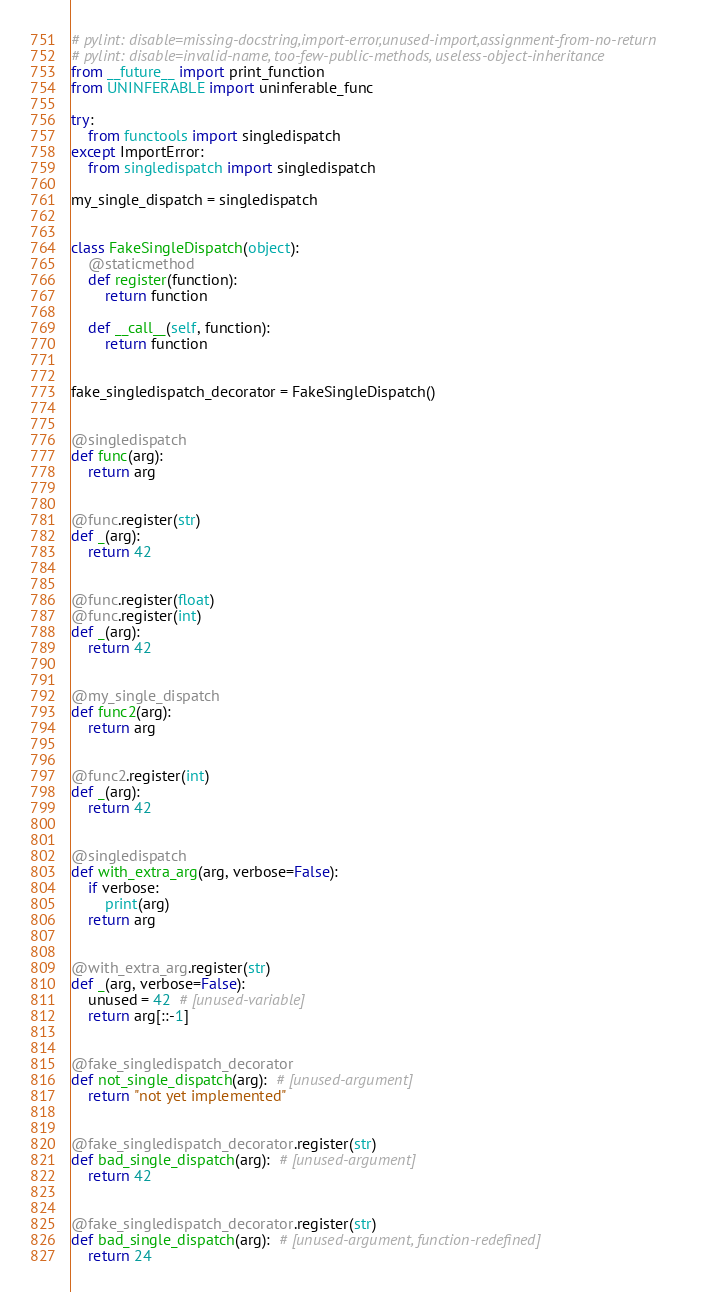<code> <loc_0><loc_0><loc_500><loc_500><_Python_># pylint: disable=missing-docstring,import-error,unused-import,assignment-from-no-return
# pylint: disable=invalid-name, too-few-public-methods, useless-object-inheritance
from __future__ import print_function
from UNINFERABLE import uninferable_func

try:
    from functools import singledispatch
except ImportError:
    from singledispatch import singledispatch

my_single_dispatch = singledispatch


class FakeSingleDispatch(object):
    @staticmethod
    def register(function):
        return function

    def __call__(self, function):
        return function


fake_singledispatch_decorator = FakeSingleDispatch()


@singledispatch
def func(arg):
    return arg


@func.register(str)
def _(arg):
    return 42


@func.register(float)
@func.register(int)
def _(arg):
    return 42


@my_single_dispatch
def func2(arg):
    return arg


@func2.register(int)
def _(arg):
    return 42


@singledispatch
def with_extra_arg(arg, verbose=False):
    if verbose:
        print(arg)
    return arg


@with_extra_arg.register(str)
def _(arg, verbose=False):
    unused = 42  # [unused-variable]
    return arg[::-1]


@fake_singledispatch_decorator
def not_single_dispatch(arg):  # [unused-argument]
    return "not yet implemented"


@fake_singledispatch_decorator.register(str)
def bad_single_dispatch(arg):  # [unused-argument]
    return 42


@fake_singledispatch_decorator.register(str)
def bad_single_dispatch(arg):  # [unused-argument, function-redefined]
    return 24
</code> 